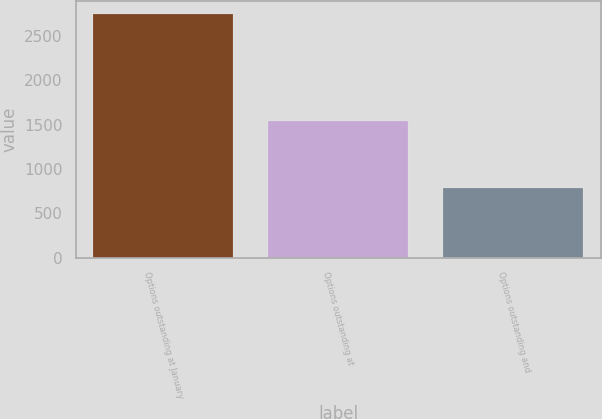<chart> <loc_0><loc_0><loc_500><loc_500><bar_chart><fcel>Options outstanding at January<fcel>Options outstanding at<fcel>Options outstanding and<nl><fcel>2752<fcel>1539<fcel>783<nl></chart> 